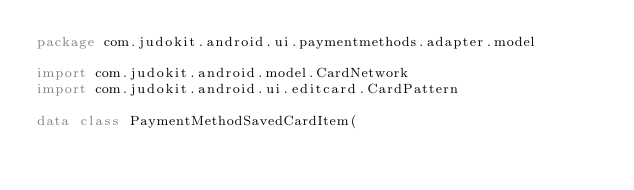Convert code to text. <code><loc_0><loc_0><loc_500><loc_500><_Kotlin_>package com.judokit.android.ui.paymentmethods.adapter.model

import com.judokit.android.model.CardNetwork
import com.judokit.android.ui.editcard.CardPattern

data class PaymentMethodSavedCardItem(</code> 